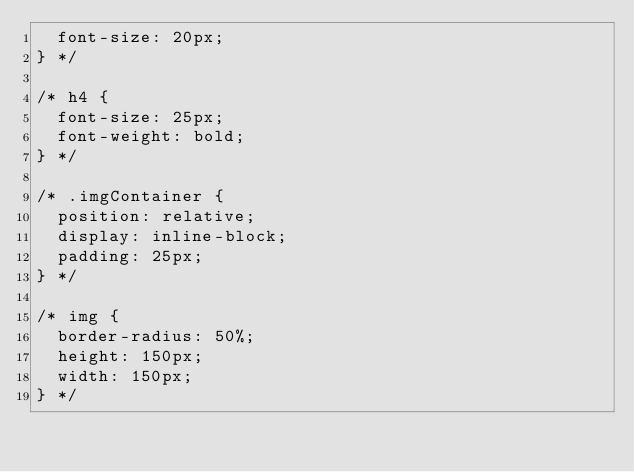<code> <loc_0><loc_0><loc_500><loc_500><_CSS_>  font-size: 20px;
} */

/* h4 {
  font-size: 25px;
  font-weight: bold;
} */

/* .imgContainer {
  position: relative;
  display: inline-block;
  padding: 25px;
} */

/* img {
  border-radius: 50%;
  height: 150px;
  width: 150px;
} */
</code> 